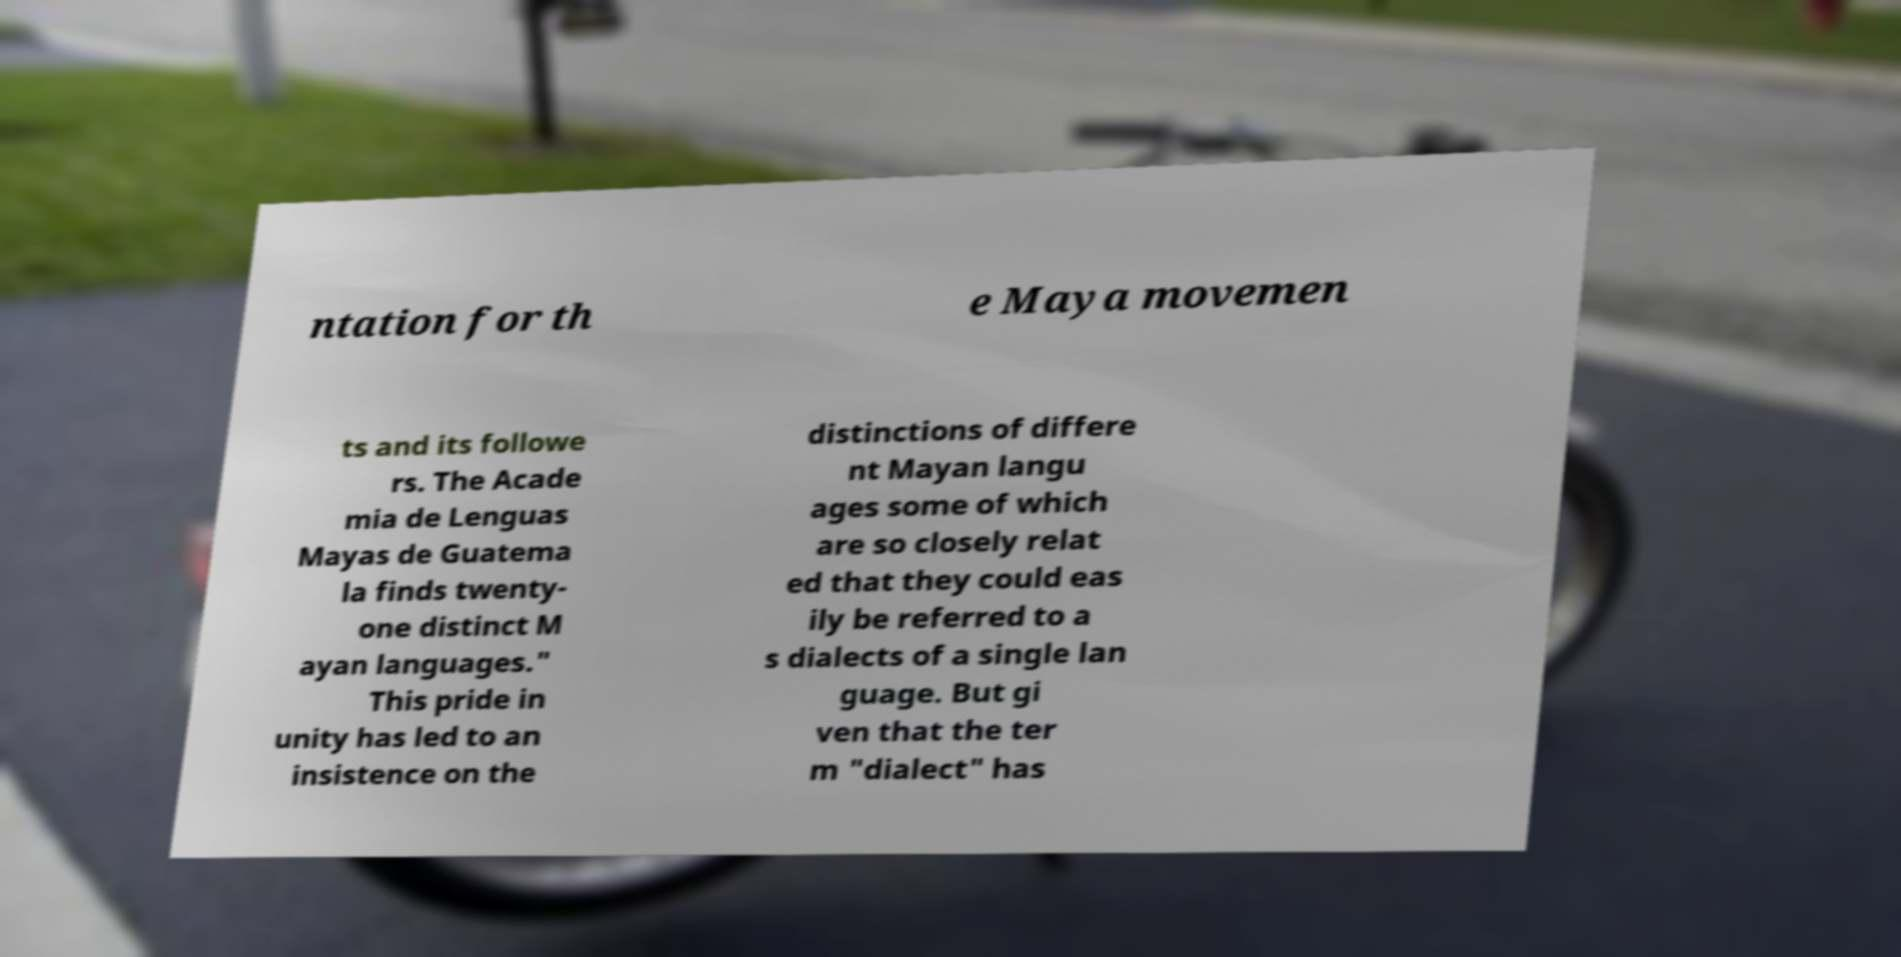Can you read and provide the text displayed in the image?This photo seems to have some interesting text. Can you extract and type it out for me? ntation for th e Maya movemen ts and its followe rs. The Acade mia de Lenguas Mayas de Guatema la finds twenty- one distinct M ayan languages." This pride in unity has led to an insistence on the distinctions of differe nt Mayan langu ages some of which are so closely relat ed that they could eas ily be referred to a s dialects of a single lan guage. But gi ven that the ter m "dialect" has 